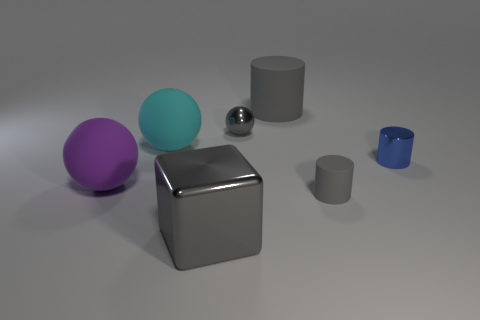Add 3 large gray rubber cylinders. How many objects exist? 10 Subtract all gray rubber cylinders. How many cylinders are left? 1 Subtract 2 balls. How many balls are left? 1 Subtract all small metal things. Subtract all blue metal blocks. How many objects are left? 5 Add 6 big gray things. How many big gray things are left? 8 Add 2 big cyan metallic cylinders. How many big cyan metallic cylinders exist? 2 Subtract all purple balls. How many balls are left? 2 Subtract 0 green cylinders. How many objects are left? 7 Subtract all cubes. How many objects are left? 6 Subtract all cyan cylinders. Subtract all red balls. How many cylinders are left? 3 